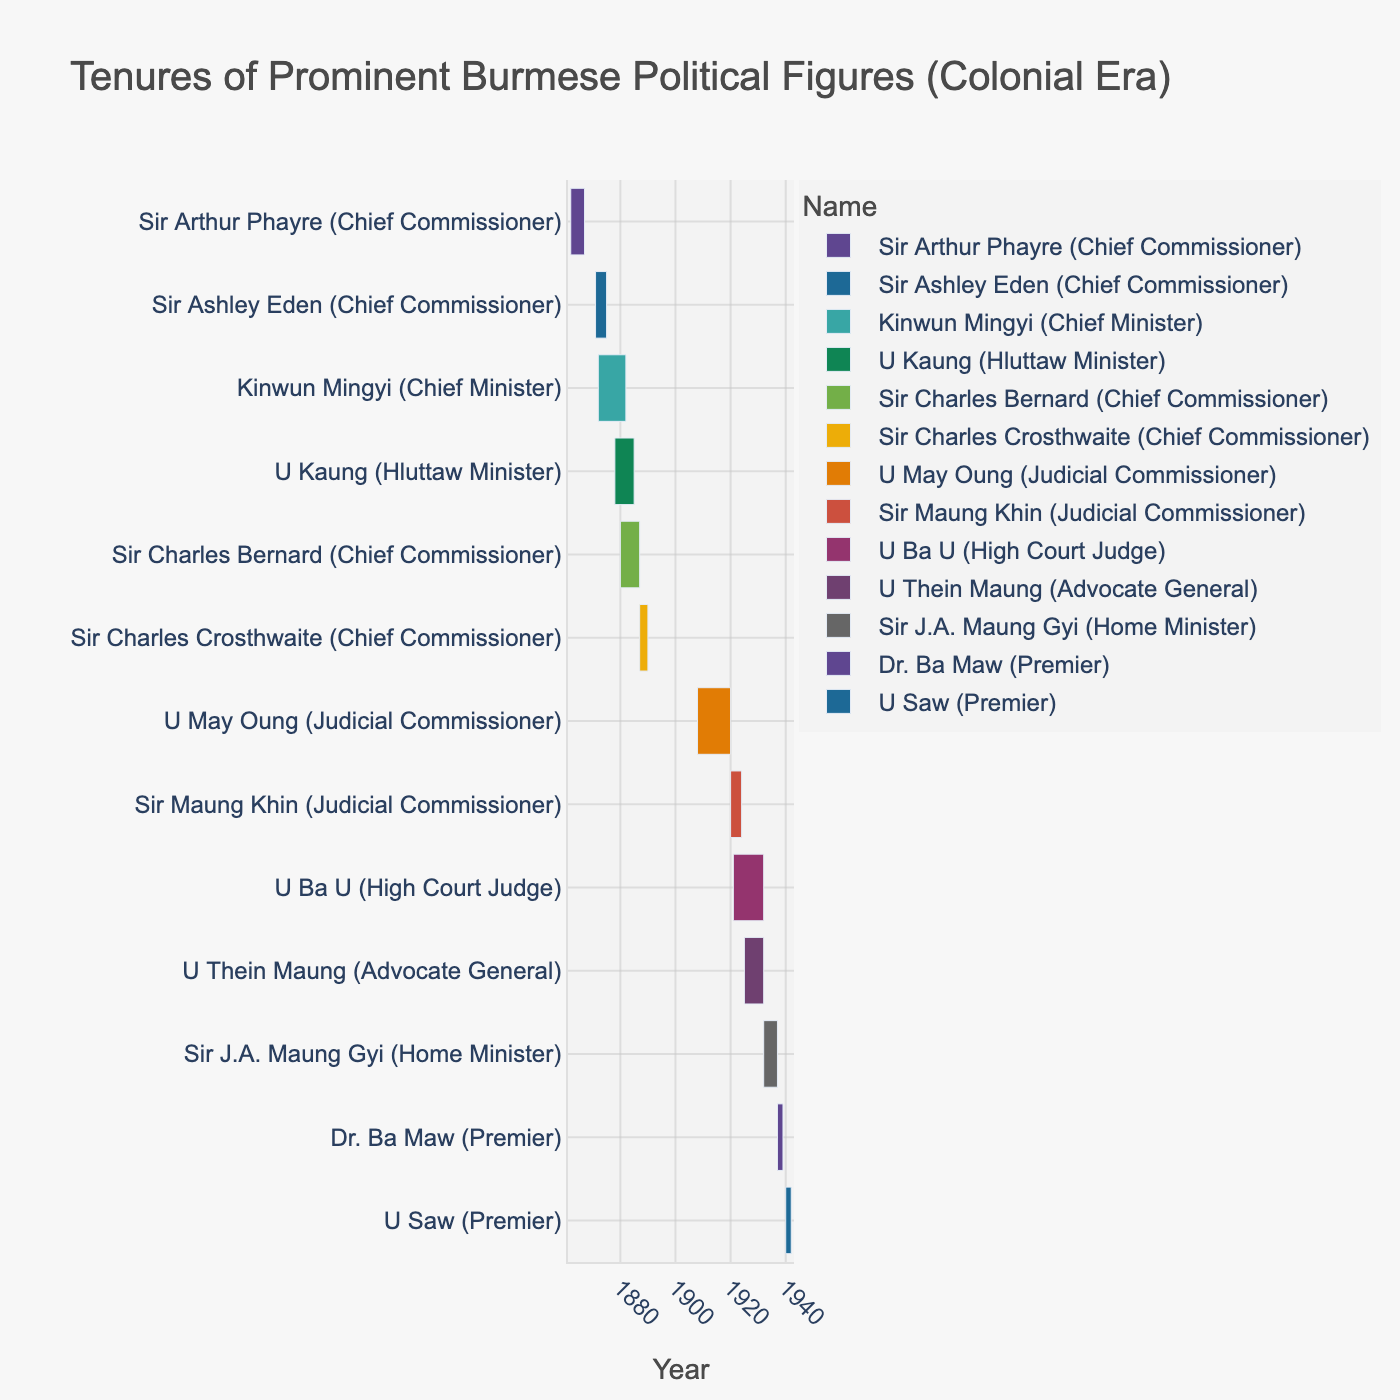What is the title of the chart? The title is displayed at the top of the chart. It describes the main purpose of the chart.
Answer: Tenures of Prominent Burmese Political Figures (Colonial Era) Which figure has the longest tenure? By examining the length of bars, we can see which one spans the longest period from start to end.
Answer: U Ba U (High Court Judge) How many figures served as Chief Commissioners? By looking at the labels on the left side (Y-axis labels), we count those with the designation "Chief Commissioner" in parentheses.
Answer: 4 Which figures had overlapping tenures during the 1920s? Identify the bars that extend through the 1920s on the X-axis, then check if their durations intersect.
Answer: U May Oung, Sir Maung Khin, U Ba U, U Thein Maung What is the tenure duration of Dr. Ba Maw as Premier? Subtract the start year from the end year for Dr. Ba Maw's tenure.
Answer: 2 years Compared to U Thein Maung, did Sir J.A. Maung Gyi serve longer? Compare the span of the bars for U Thein Maung and Sir J.A. Maung Gyi.
Answer: No Which figures' tenures overlap the period 1932 to 1937? Look at bars that extend through 1932 to 1937 on the X-axis, and list the figures.
Answer: U Ba U, U Thein Maung, Sir J.A. Maung Gyi Who were in office during U Saw's tenure as Premier? Identify U Saw's tenure on the chart and then list any figures whose tenures overlap this period.
Answer: Sir J.A. Maung Gyi, U Ba U, U Thein Maung Who served immediately before Sir Charles Crosthwaite? Find Sir Charles Crosthwaite's bar and check the figure whose tenure ends just before his starts.
Answer: Sir Charles Bernard Who had the shortest tenure, and what was their role? Determine the shortest bar in the chart and identify the figure and their role.
Answer: U Saw (Premier) 